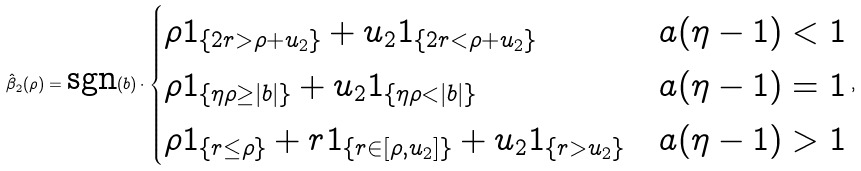Convert formula to latex. <formula><loc_0><loc_0><loc_500><loc_500>\hat { \beta } _ { 2 } ( \rho ) = \text {sgn} ( b ) \cdot \begin{cases} \rho 1 _ { \{ 2 r > \rho + u _ { 2 } \} } + u _ { 2 } 1 _ { \{ 2 r < \rho + u _ { 2 } \} } & a ( \eta - 1 ) < 1 \\ \rho 1 _ { \{ \eta \rho \geq | b | \} } + u _ { 2 } 1 _ { \{ \eta \rho < | b | \} } & a ( \eta - 1 ) = 1 \\ \rho 1 _ { \{ r \leq \rho \} } + r 1 _ { \{ r \in [ \rho , u _ { 2 } ] \} } + u _ { 2 } 1 _ { \{ r > u _ { 2 } \} } & a ( \eta - 1 ) > 1 \end{cases} ,</formula> 